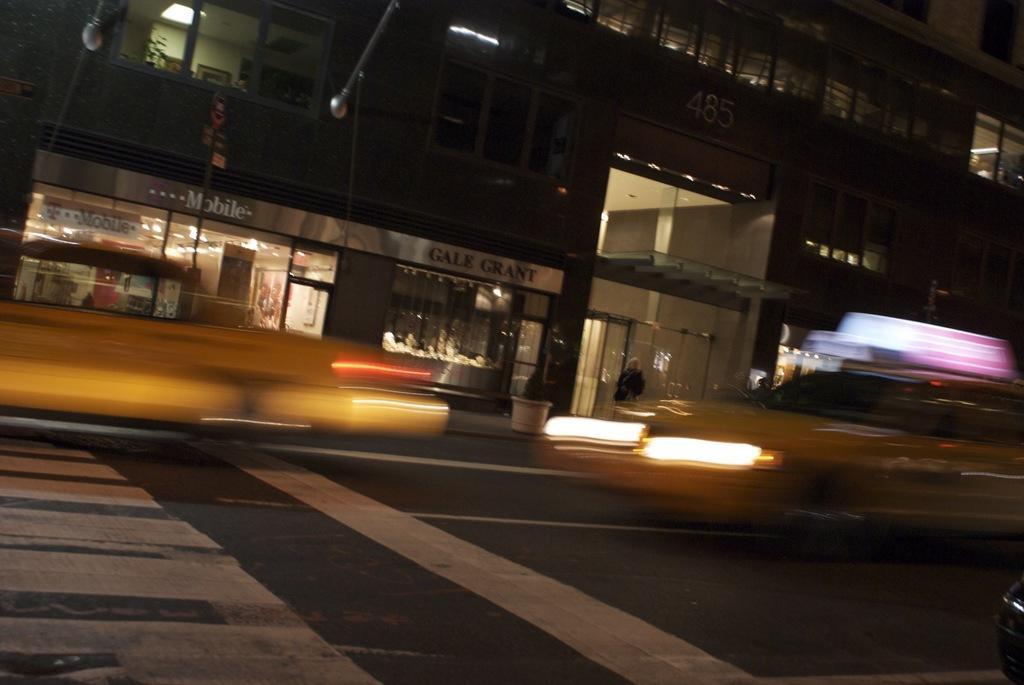Describe this image in one or two sentences. In this image I can see a road , on the road I can see lights and flower pot and building and vehicle and windows on the building and glasses. 